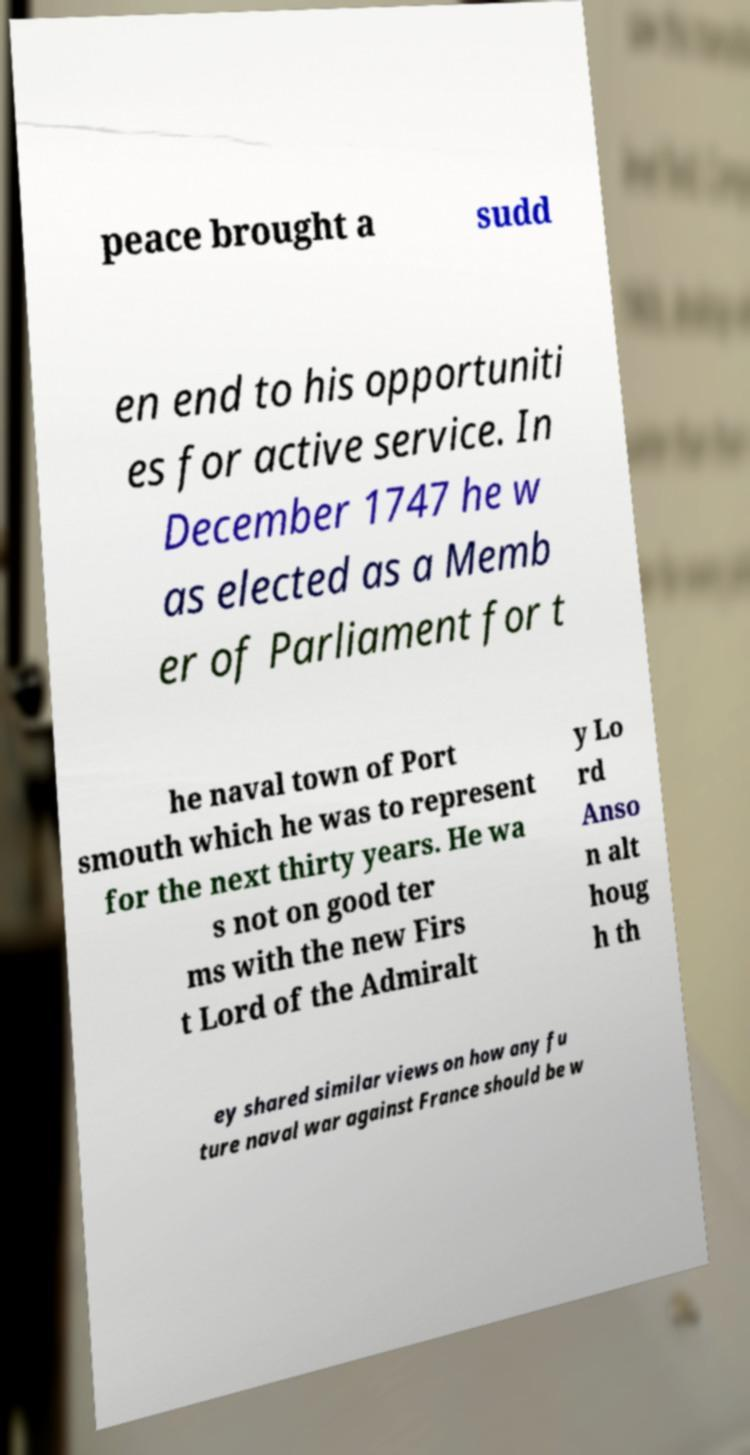Please read and relay the text visible in this image. What does it say? peace brought a sudd en end to his opportuniti es for active service. In December 1747 he w as elected as a Memb er of Parliament for t he naval town of Port smouth which he was to represent for the next thirty years. He wa s not on good ter ms with the new Firs t Lord of the Admiralt y Lo rd Anso n alt houg h th ey shared similar views on how any fu ture naval war against France should be w 